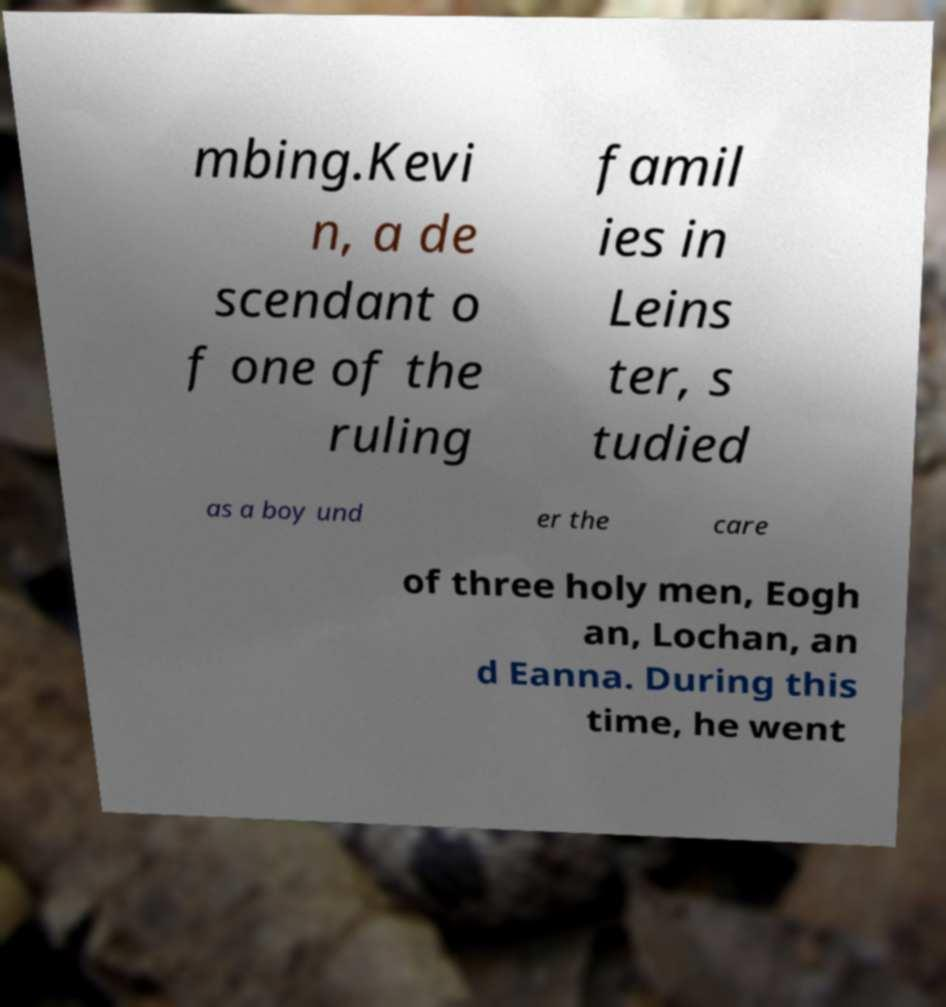Please identify and transcribe the text found in this image. mbing.Kevi n, a de scendant o f one of the ruling famil ies in Leins ter, s tudied as a boy und er the care of three holy men, Eogh an, Lochan, an d Eanna. During this time, he went 